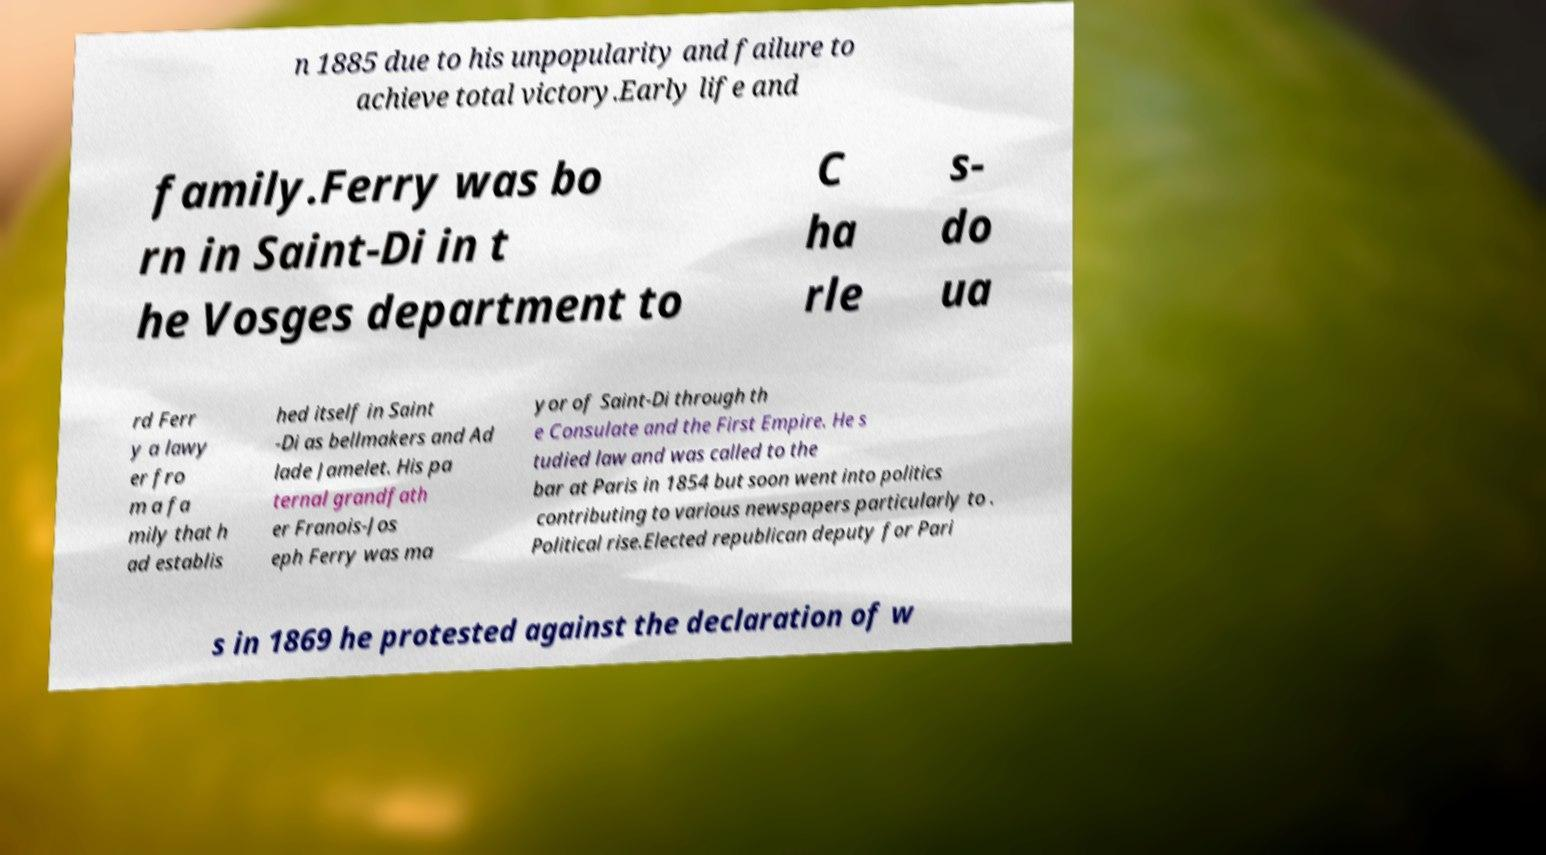Please identify and transcribe the text found in this image. n 1885 due to his unpopularity and failure to achieve total victory.Early life and family.Ferry was bo rn in Saint-Di in t he Vosges department to C ha rle s- do ua rd Ferr y a lawy er fro m a fa mily that h ad establis hed itself in Saint -Di as bellmakers and Ad lade Jamelet. His pa ternal grandfath er Franois-Jos eph Ferry was ma yor of Saint-Di through th e Consulate and the First Empire. He s tudied law and was called to the bar at Paris in 1854 but soon went into politics contributing to various newspapers particularly to . Political rise.Elected republican deputy for Pari s in 1869 he protested against the declaration of w 